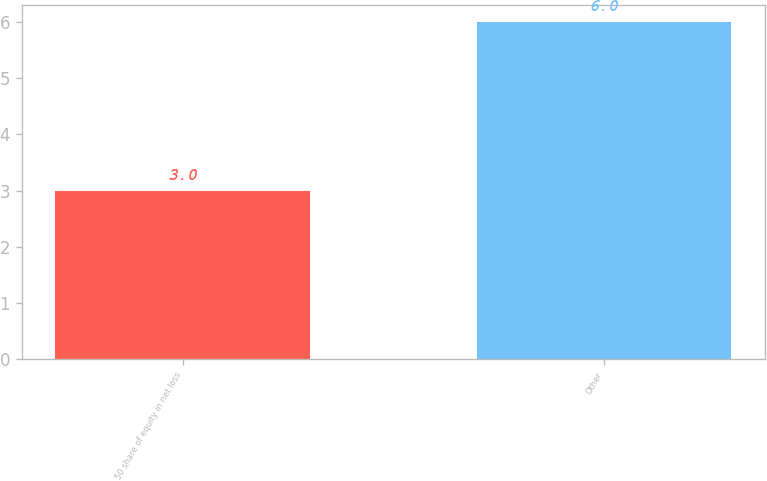Convert chart to OTSL. <chart><loc_0><loc_0><loc_500><loc_500><bar_chart><fcel>50 share of equity in net loss<fcel>Other<nl><fcel>3<fcel>6<nl></chart> 